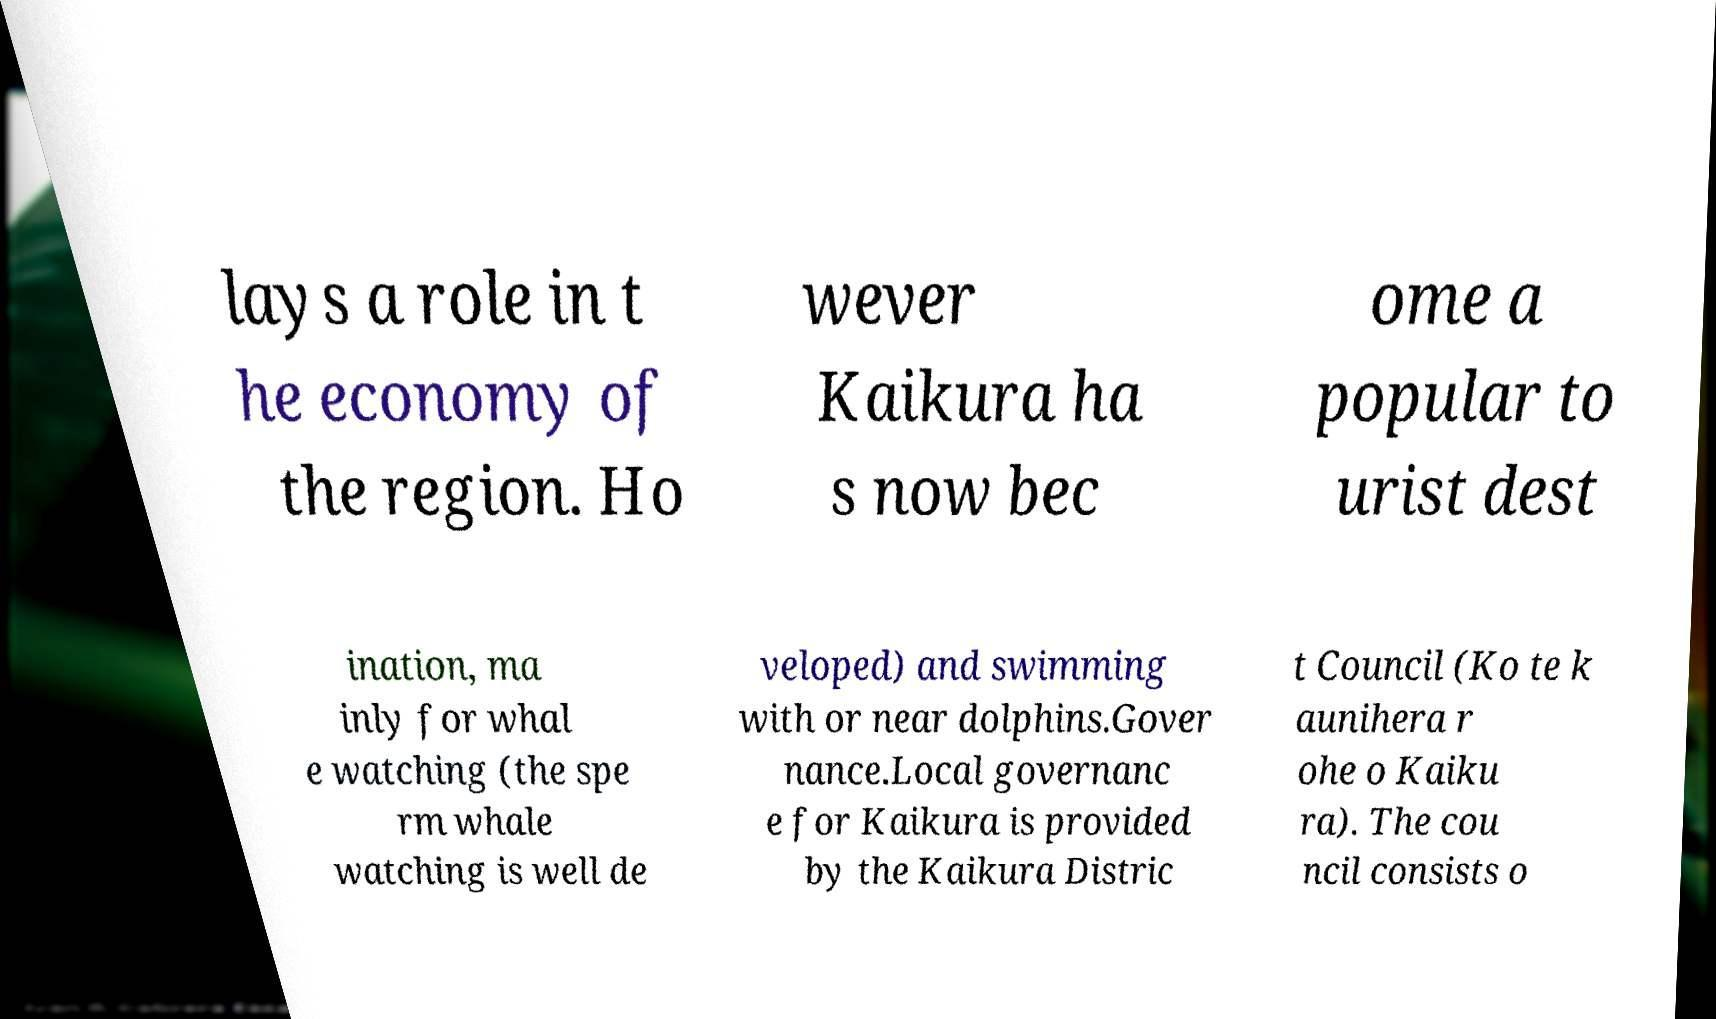There's text embedded in this image that I need extracted. Can you transcribe it verbatim? lays a role in t he economy of the region. Ho wever Kaikura ha s now bec ome a popular to urist dest ination, ma inly for whal e watching (the spe rm whale watching is well de veloped) and swimming with or near dolphins.Gover nance.Local governanc e for Kaikura is provided by the Kaikura Distric t Council (Ko te k aunihera r ohe o Kaiku ra). The cou ncil consists o 